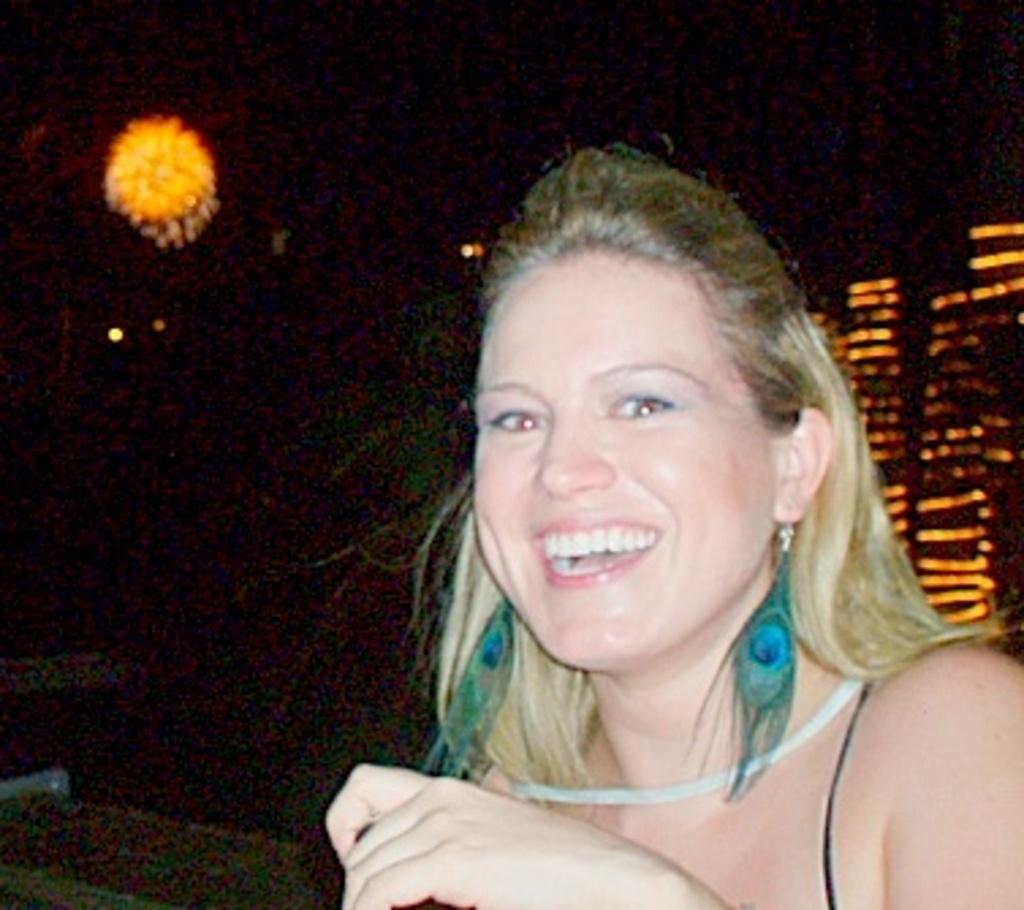How would you summarize this image in a sentence or two? In this image there is one women is on the right side of this image and there are some lights in the background. 